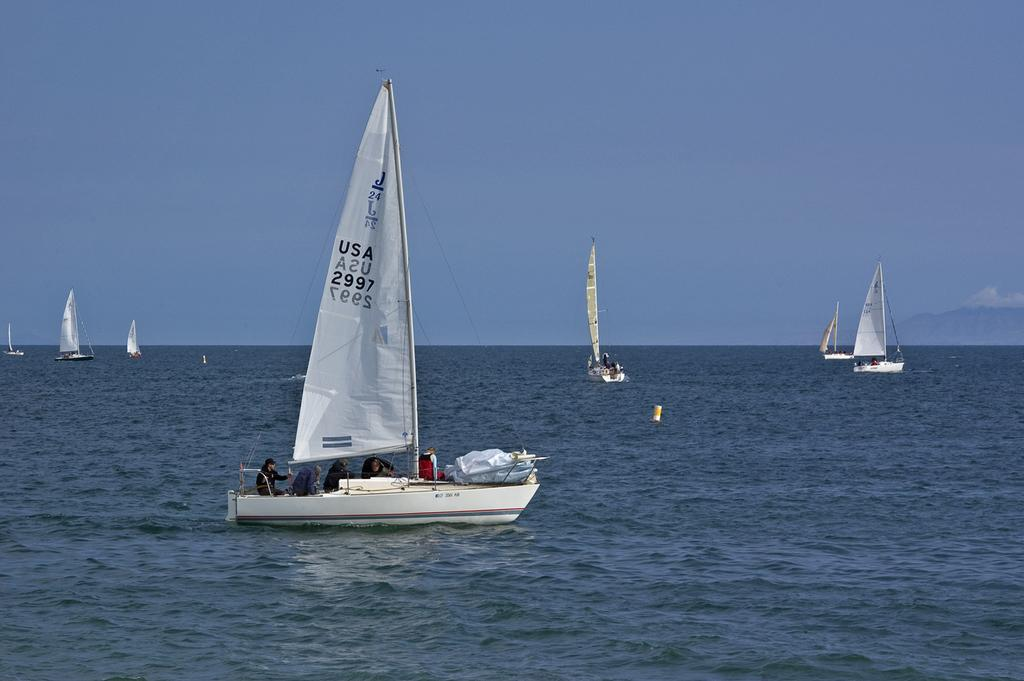What is the main subject in the center of the image? There is a boat in the center of the image. What is located at the bottom of the image? There is water at the bottom of the image. Can you describe the background of the image? There are boats visible in the background of the image, and the sky is also visible. What type of tent can be seen in the image? There is no tent present in the image; it features a boat in the water with other boats in the background. 